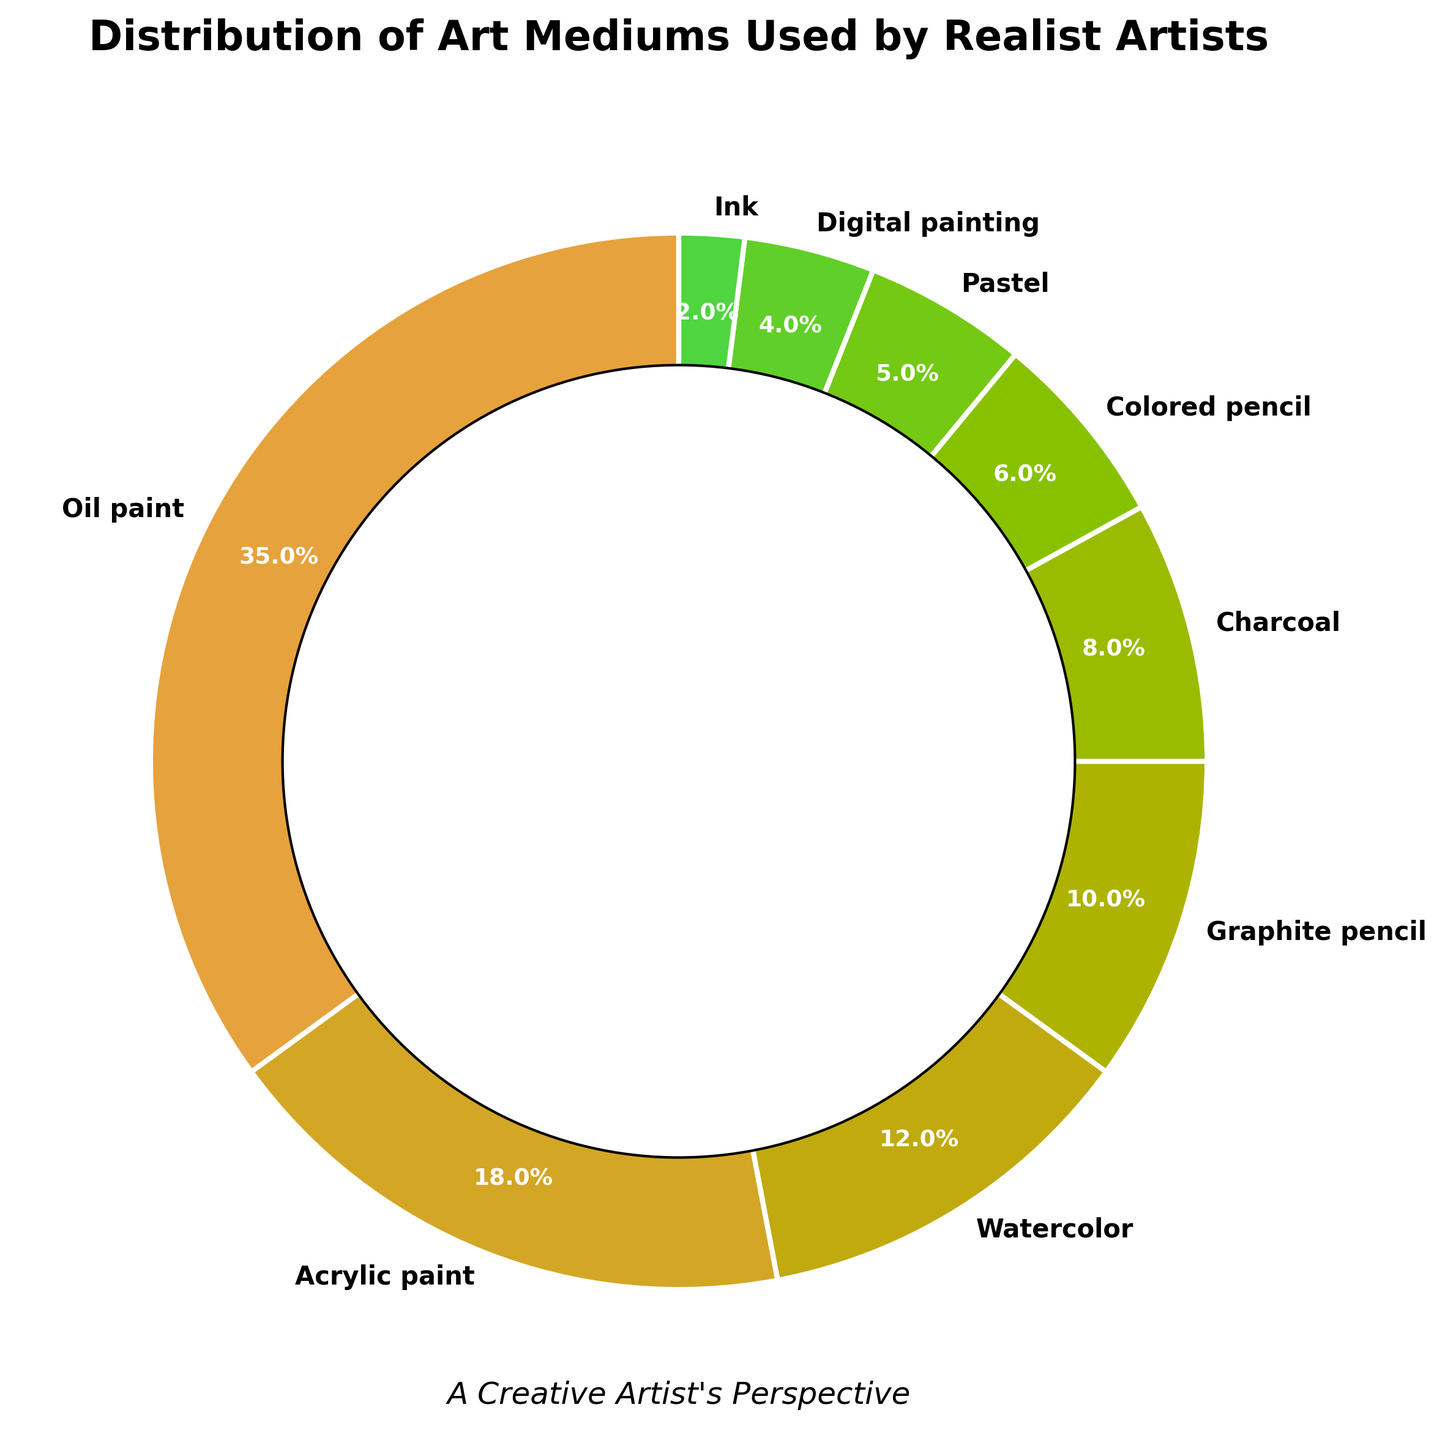Which medium has the highest usage among realist artists? The chart shows that oil paint has the largest segment, indicating its highest usage among realist artists.
Answer: Oil paint How much more popular is oil paint compared to watercolor? Oil paint accounts for 35% of the total while watercolor accounts for 12%. The difference can be calculated as 35% - 12% = 23%.
Answer: 23% What is the combined percentage of traditional drawing tools (graphite pencil and charcoal)? Graphite pencil is 10% and charcoal is 8%. Adding these two percentages gives 10% + 8% = 18%.
Answer: 18% Which medium is used less frequently, pastel or digital painting? The chart shows that digital painting has a smaller segment compared to pastel. Digital painting is at 4%, while pastel is at 5%.
Answer: Digital painting How much less popular is colored pencil compared to acrylic paint? Acrylic paint accounts for 18% and colored pencil accounts for 6%. The difference is 18% - 6% = 12%.
Answer: 12% What's the total percentage of media that fall under painting (oil paint, acrylic paint, watercolor, and digital painting)? Oil paint (35%) + acrylic paint (18%) + watercolor (12%) + digital painting (4%) = 69%.
Answer: 69% Between charcoal and ink, which medium occupies a smaller proportion, and by how much? Ink is at 2% while charcoal is at 8%. The difference is 8% - 2% = 6%.
Answer: Ink, 6% Is graphite pencil usage more than double that of ink? Graphite pencil is 10%, while ink is 2%. Doubling the percentage of ink results in 2% * 2 = 4%. Since 10% is greater than 4%, usage of graphite pencil is indeed more than double that of ink.
Answer: Yes What is the average percentage of watercolor, graphite pencil, and charcoal usage? Watercolor (12%) + graphite pencil (10%) + charcoal (8%) = 30%. The average is 30% / 3 = 10%.
Answer: 10% Which three media are used the least and what is their combined percentage? The least three used media are digital painting (4%), ink (2%), and pastel (5%). Adding them gives 4% + 2% + 5% = 11%.
Answer: Digital painting, ink, pastel; 11% 